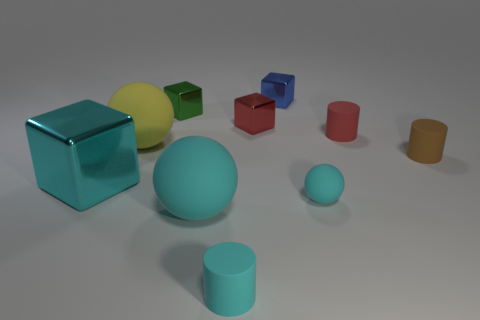Subtract all cyan blocks. How many blocks are left? 3 Subtract all yellow balls. How many balls are left? 2 Subtract all blocks. How many objects are left? 6 Subtract 3 cubes. How many cubes are left? 1 Add 6 red shiny things. How many red shiny things exist? 7 Subtract 0 purple cylinders. How many objects are left? 10 Subtract all cyan blocks. Subtract all red balls. How many blocks are left? 3 Subtract all red cylinders. How many yellow balls are left? 1 Subtract all tiny gray rubber cylinders. Subtract all small red cubes. How many objects are left? 9 Add 2 yellow matte spheres. How many yellow matte spheres are left? 3 